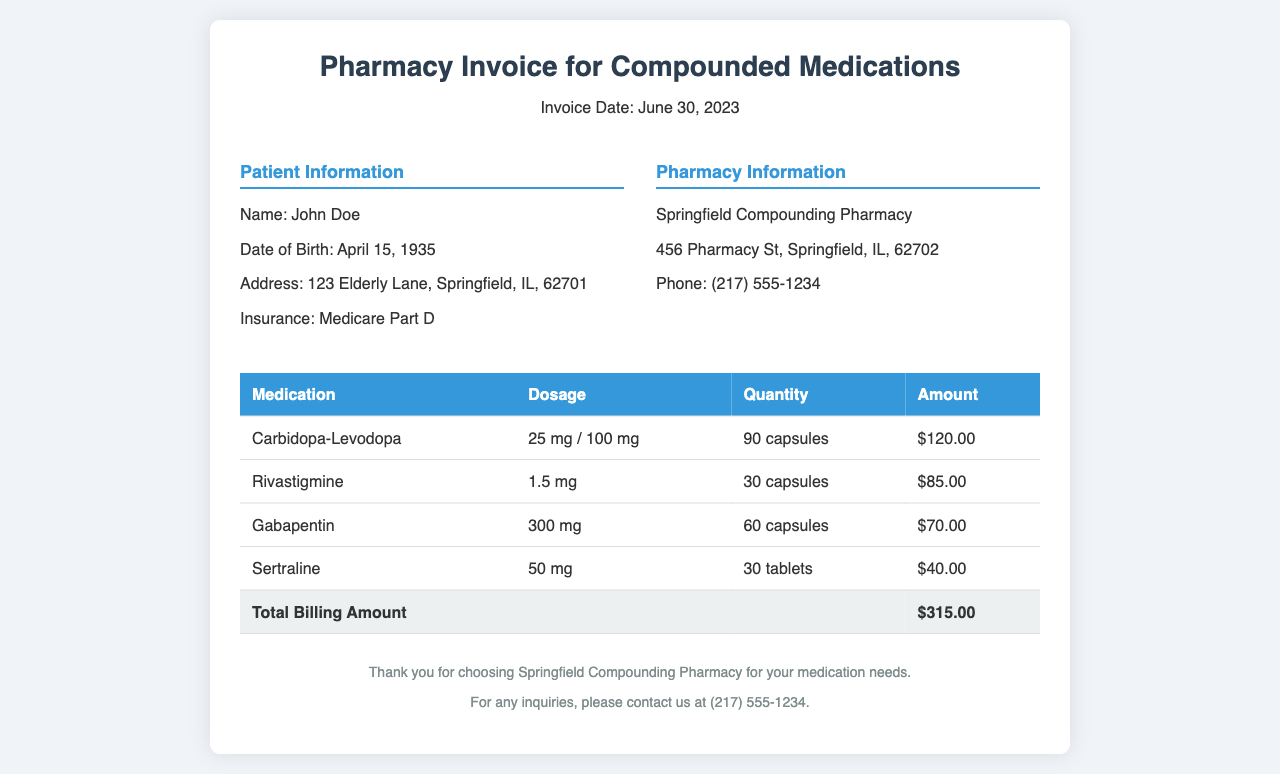What is the patient's name? The patient's name is listed in the Patient Information section of the invoice.
Answer: John Doe What is the total billing amount? The total billing amount is specified at the bottom of the invoice table.
Answer: $315.00 How many capsules of Rivastigmine were prescribed? The quantity of Rivastigmine is shown in the table, stating how many capsules were prescribed.
Answer: 30 capsules What is the dosage of Carbidopa-Levodopa? The dosage for Carbidopa-Levodopa is mentioned in the medication table.
Answer: 25 mg / 100 mg Which pharmacy issued the invoice? The name of the pharmacy is provided in the Pharmacy Information section of the document.
Answer: Springfield Compounding Pharmacy How many different medications are listed in the invoice? The number of medications can be counted from the rows in the medication table.
Answer: 4 What is the address of the pharmacy? The pharmacy's address is provided in the Pharmacy Information section of the invoice.
Answer: 456 Pharmacy St, Springfield, IL, 62702 What insurance does the patient have? The type of insurance is specified under the Patient Information section.
Answer: Medicare Part D What is the dosage of Gabapentin? The dosage for Gabapentin is clearly mentioned in the medication table.
Answer: 300 mg 